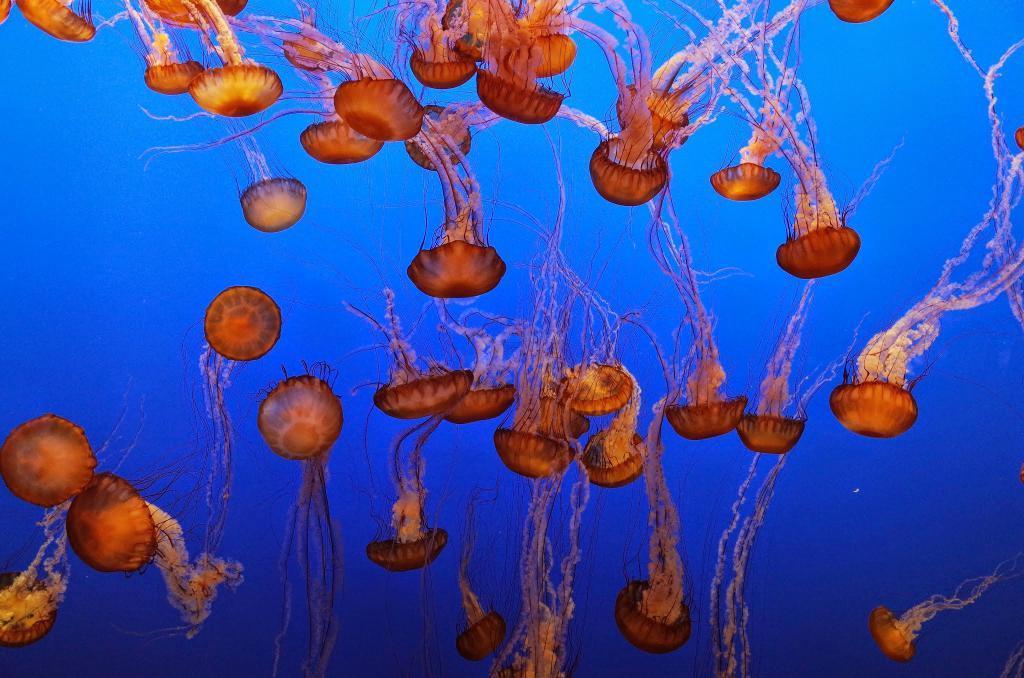Please provide a concise description of this image. There are many jellyfishes in the water. 